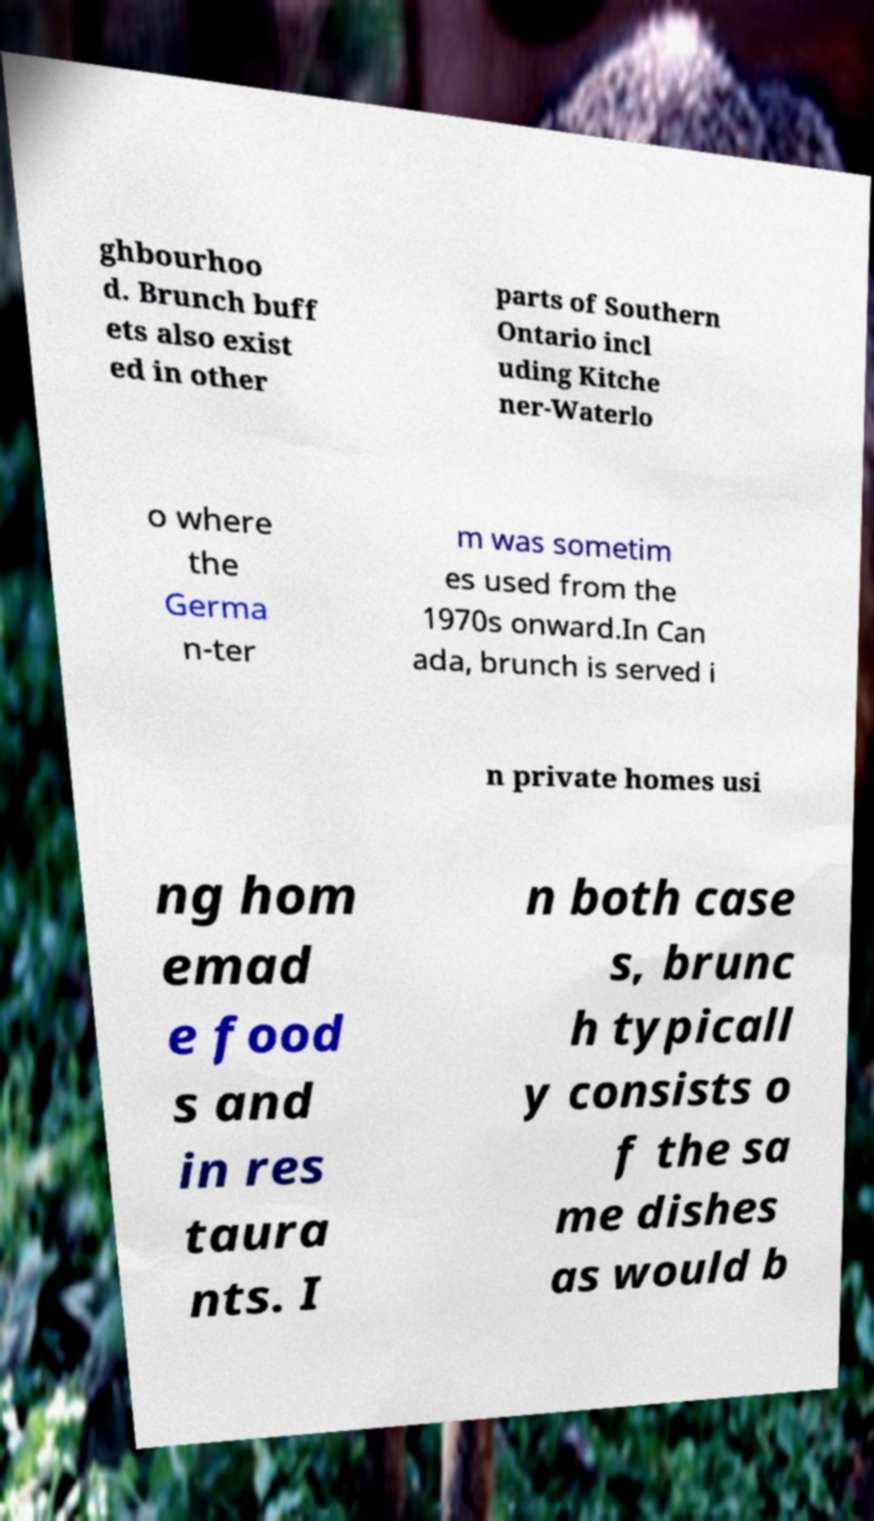There's text embedded in this image that I need extracted. Can you transcribe it verbatim? ghbourhoo d. Brunch buff ets also exist ed in other parts of Southern Ontario incl uding Kitche ner-Waterlo o where the Germa n-ter m was sometim es used from the 1970s onward.In Can ada, brunch is served i n private homes usi ng hom emad e food s and in res taura nts. I n both case s, brunc h typicall y consists o f the sa me dishes as would b 